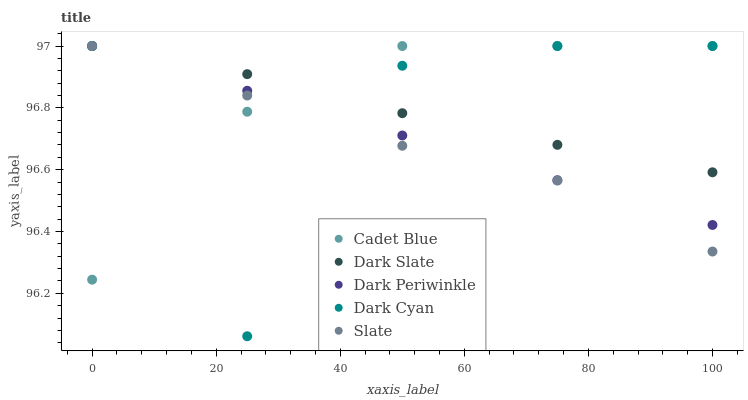Does Slate have the minimum area under the curve?
Answer yes or no. Yes. Does Cadet Blue have the maximum area under the curve?
Answer yes or no. Yes. Does Dark Slate have the minimum area under the curve?
Answer yes or no. No. Does Dark Slate have the maximum area under the curve?
Answer yes or no. No. Is Dark Periwinkle the smoothest?
Answer yes or no. Yes. Is Dark Cyan the roughest?
Answer yes or no. Yes. Is Dark Slate the smoothest?
Answer yes or no. No. Is Dark Slate the roughest?
Answer yes or no. No. Does Dark Cyan have the lowest value?
Answer yes or no. Yes. Does Slate have the lowest value?
Answer yes or no. No. Does Dark Periwinkle have the highest value?
Answer yes or no. Yes. Does Cadet Blue intersect Dark Cyan?
Answer yes or no. Yes. Is Cadet Blue less than Dark Cyan?
Answer yes or no. No. Is Cadet Blue greater than Dark Cyan?
Answer yes or no. No. 